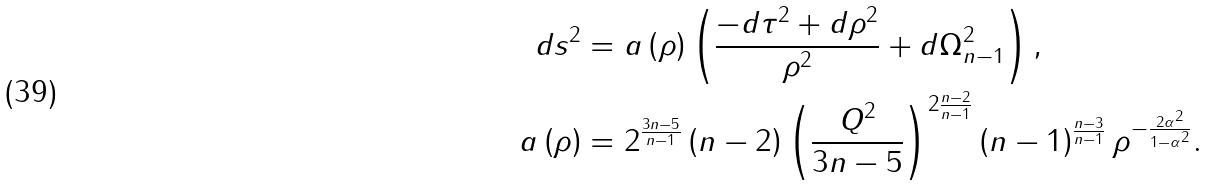Convert formula to latex. <formula><loc_0><loc_0><loc_500><loc_500>d s ^ { 2 } & = a \left ( \rho \right ) \left ( \frac { - d \tau ^ { 2 } + d \rho ^ { 2 } } { \rho ^ { 2 } } + d \Omega _ { n - 1 } ^ { 2 } \right ) , \\ a \left ( \rho \right ) & = 2 ^ { \frac { 3 n - 5 } { n - 1 } } \left ( n - 2 \right ) \left ( \frac { Q ^ { 2 } } { 3 n - 5 } \right ) ^ { 2 \frac { n - 2 } { n - 1 } } \left ( n - 1 \right ) ^ { \frac { n - 3 } { n - 1 } } \rho ^ { - \frac { 2 \alpha ^ { 2 } } { 1 - \alpha ^ { 2 } } } .</formula> 